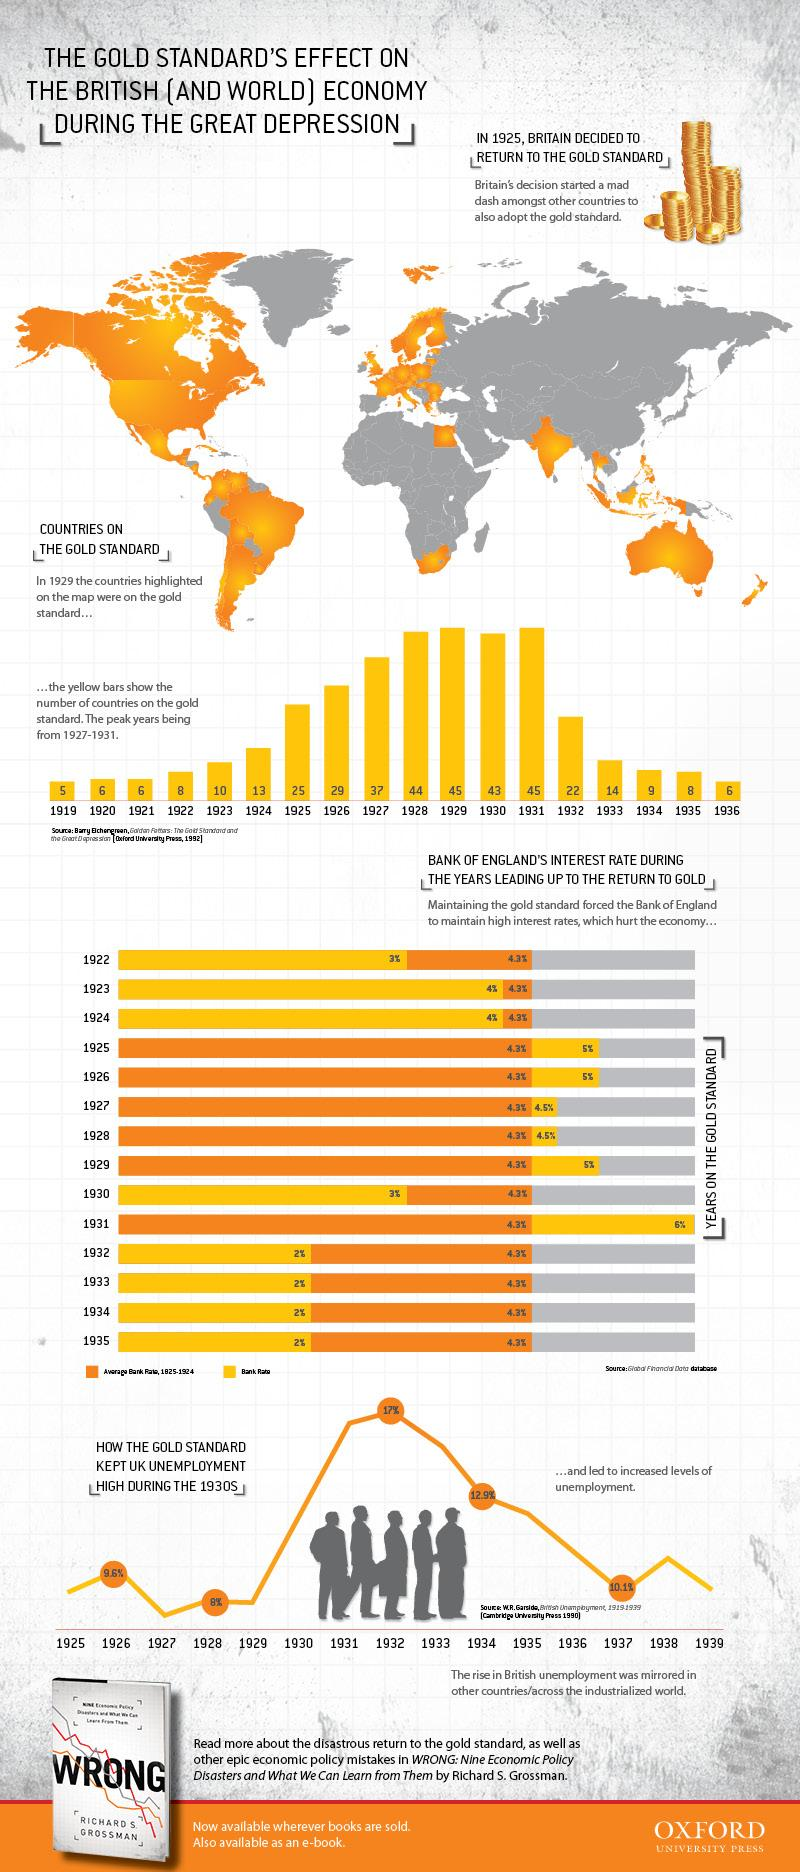Mention a couple of crucial points in this snapshot. In 1931, 45 countries were on the gold standard. In 1924, 13 countries were on the gold standard. 